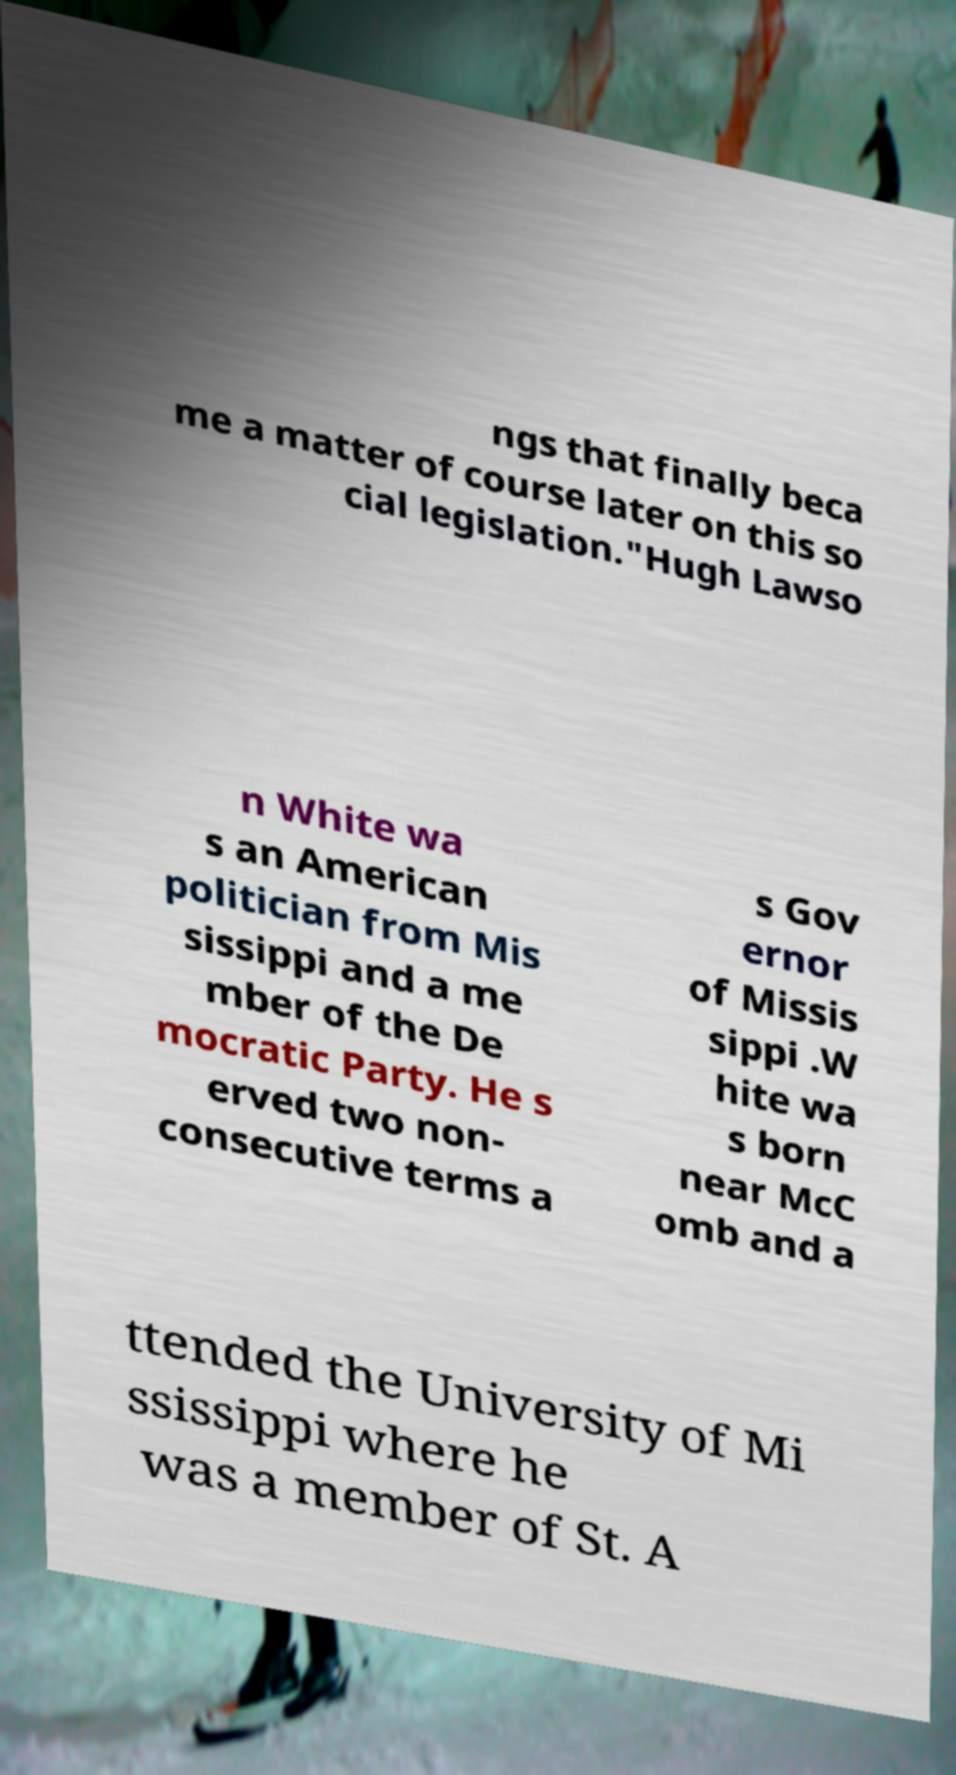What messages or text are displayed in this image? I need them in a readable, typed format. ngs that finally beca me a matter of course later on this so cial legislation."Hugh Lawso n White wa s an American politician from Mis sissippi and a me mber of the De mocratic Party. He s erved two non- consecutive terms a s Gov ernor of Missis sippi .W hite wa s born near McC omb and a ttended the University of Mi ssissippi where he was a member of St. A 